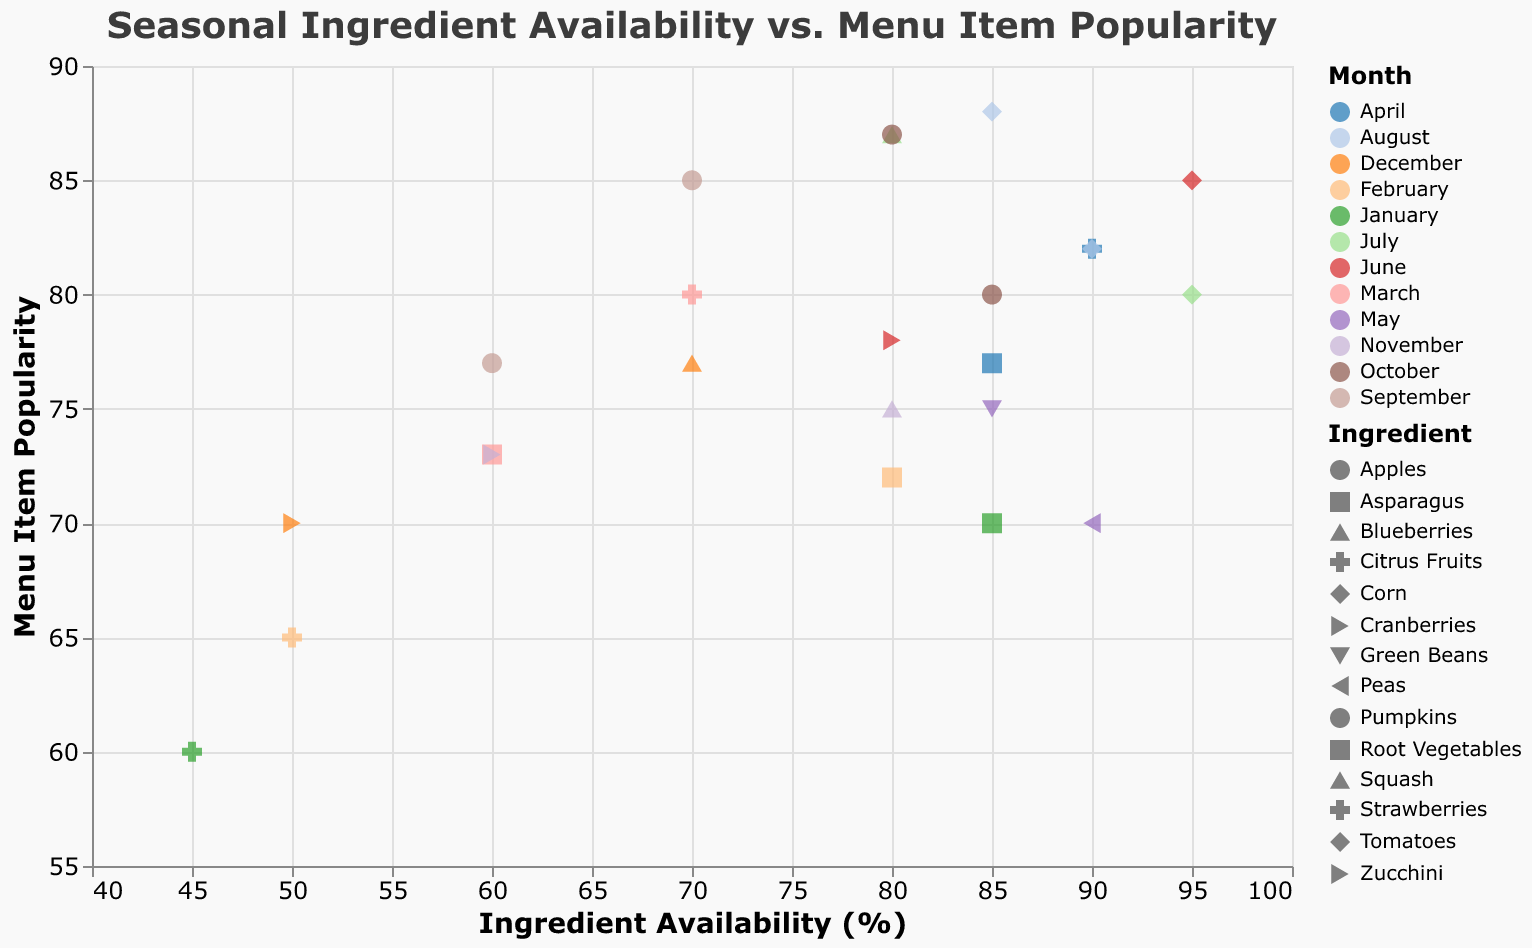What is the title of the figure? The title is typically located at the top of the figure and summarizes the content of the plot.
Answer: Seasonal Ingredient Availability vs. Menu Item Popularity Based on the plot, which month has the highest availability of Tomatoes? The x-axis represents the Availability of ingredients, and the color legend helps to identify months. Look for the month where Tomatoes have the highest availability.
Answer: June Which menu item was the most popular in July? To find which menu item was the most popular in July, look at the data points for July (identified by their color) and check the popularity values on the y-axis.
Answer: Blueberry Muffin How does the popularity of Lemon Chicken change from January to February? Compare the y-axis values for Lemon Chicken in January and February. Look for the corresponding points for January and February based on the color legend.
Answer: It increases from 60 to 65 Which ingredient has the highest average availability? Calculate the average availability for each ingredient by summing their availability values and dividing by the number of data points for that ingredient. Compare these averages.
Answer: Corn How do the availability and popularity of Pumpkins in October compare to September? Look at the x-axis (availability) and y-axis (popularity) values for Pumpkins in both months by identifying the corresponding points. Compare these values.
Answer: Availability increases from 60 to 85, and popularity increases from 77 to 80 What is the range of popularity values for ingredients available in August? Identify the points corresponding to August using the color legend, check their popularity values on the y-axis, then calculate the range (max - min).
Answer: 88 - 70 = 18 Which month has the most variability in menu item popularity? For each month, look at the spread of data points along the y-axis. Find the month with the greatest spread in popularity values.
Answer: August During which month is Asparagus most popular? Identify the points representing Asparagus (by their shape) and find the one with the highest popularity value on the y-axis.
Answer: April Is there a correlation between ingredient availability and menu item popularity? Observe the overall pattern of data points. Determine if higher availability tends to correspond with higher popularity or if there's no clear trend.
Answer: There is a slight positive correlation 